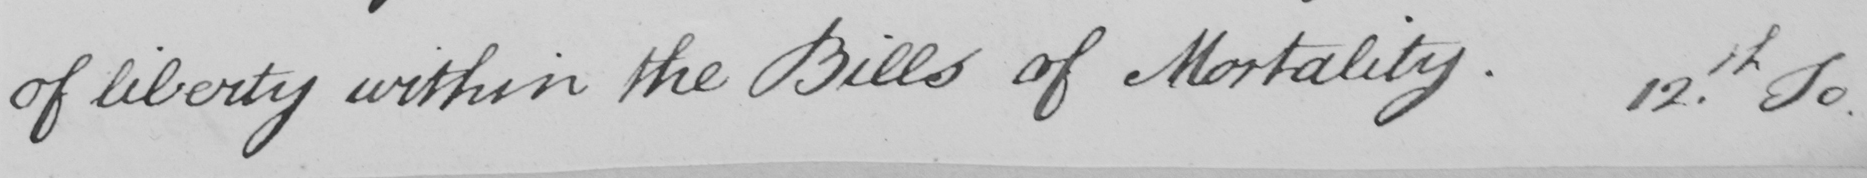Please transcribe the handwritten text in this image. of liberty within the Bills of Mortality . 12th To 